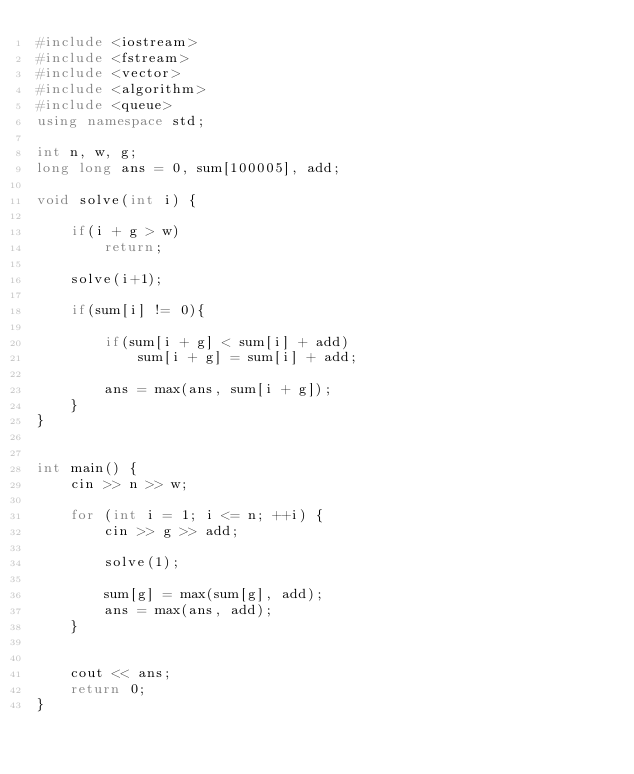<code> <loc_0><loc_0><loc_500><loc_500><_C++_>#include <iostream>
#include <fstream>
#include <vector>
#include <algorithm>
#include <queue>
using namespace std;

int n, w, g;
long long ans = 0, sum[100005], add;

void solve(int i) {

    if(i + g > w)
        return;

    solve(i+1);

    if(sum[i] != 0){

        if(sum[i + g] < sum[i] + add)
            sum[i + g] = sum[i] + add;

        ans = max(ans, sum[i + g]);
    }
}


int main() {
    cin >> n >> w;

    for (int i = 1; i <= n; ++i) {
        cin >> g >> add;

        solve(1);

        sum[g] = max(sum[g], add);
        ans = max(ans, add);
    }


    cout << ans;
    return 0;
}
</code> 